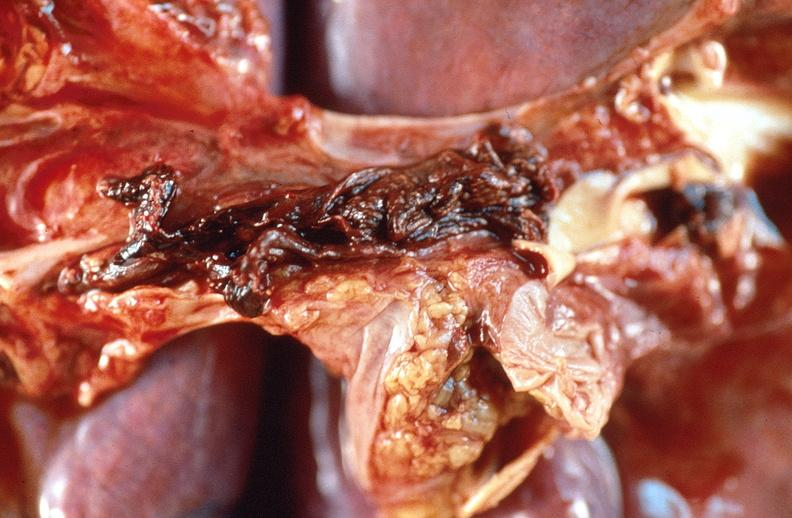where is this?
Answer the question using a single word or phrase. Lung 